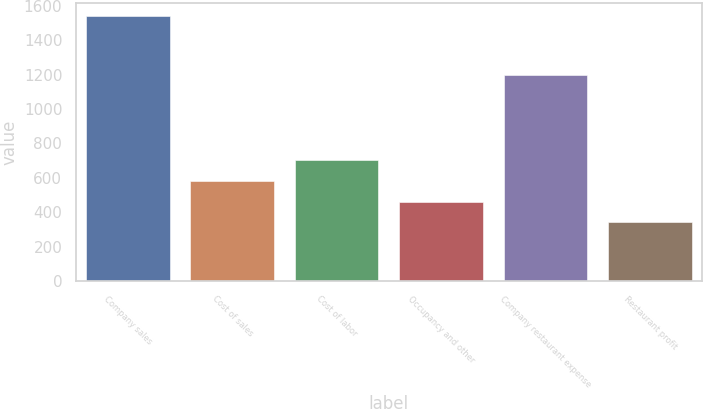Convert chart to OTSL. <chart><loc_0><loc_0><loc_500><loc_500><bar_chart><fcel>Company sales<fcel>Cost of sales<fcel>Cost of labor<fcel>Occupancy and other<fcel>Company restaurant expense<fcel>Restaurant profit<nl><fcel>1540<fcel>581.6<fcel>701.4<fcel>461.8<fcel>1198<fcel>342<nl></chart> 